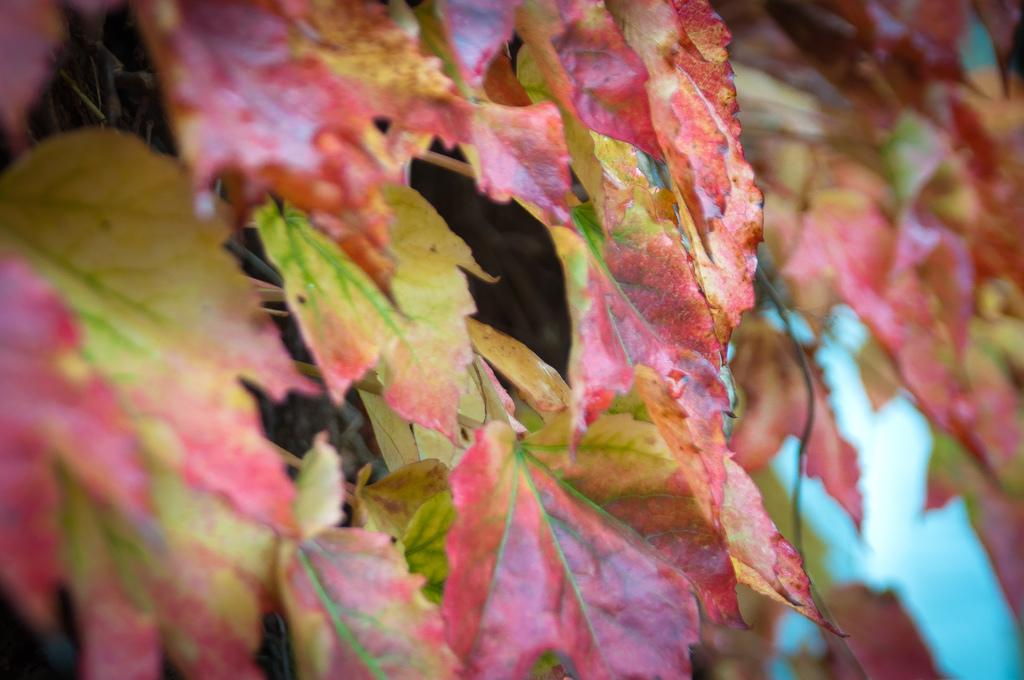What type of natural elements can be seen in the image? There are leaves in the image. What colors are present on the leaves? The leaves have pink, yellow, and green colors. What type of company is holding a meeting in the hall depicted in the image? There is no company or hall present in the image; it only features leaves with pink, yellow, and green colors. 